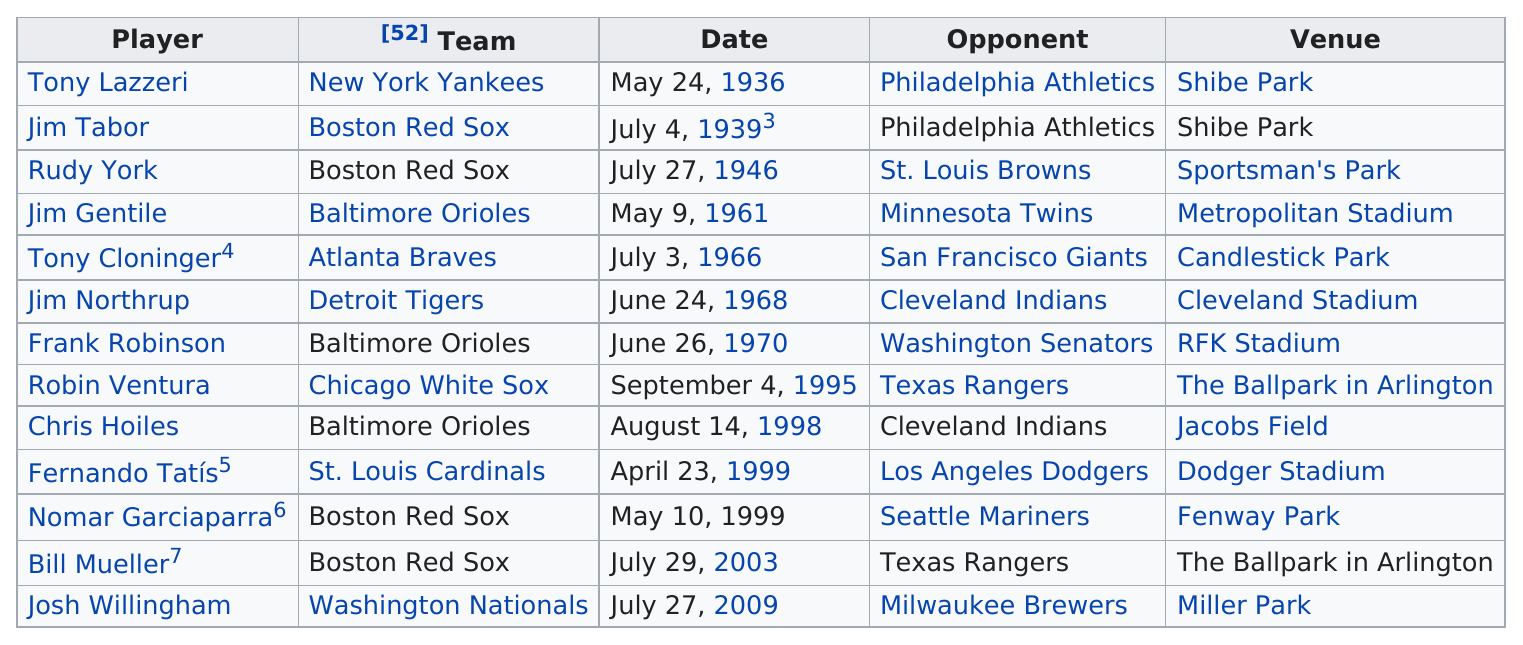Give some essential details in this illustration. In 1999, a player known as Nomar Garciaparra accomplished a feat while playing for the Boston Red Sox, but what was the name of this player? On July 27, 1946, the Boston Red Sox faced off against the St. Louis Browns, resulting in a challenging and memorable game for both teams. Tony Lazzeri, the first major league hitter in history, achieved the remarkable feat of hitting two grand slams in one game! It is three years between Tony Lazzeri and Jim Tabor. There are a total of 13 players listed. 